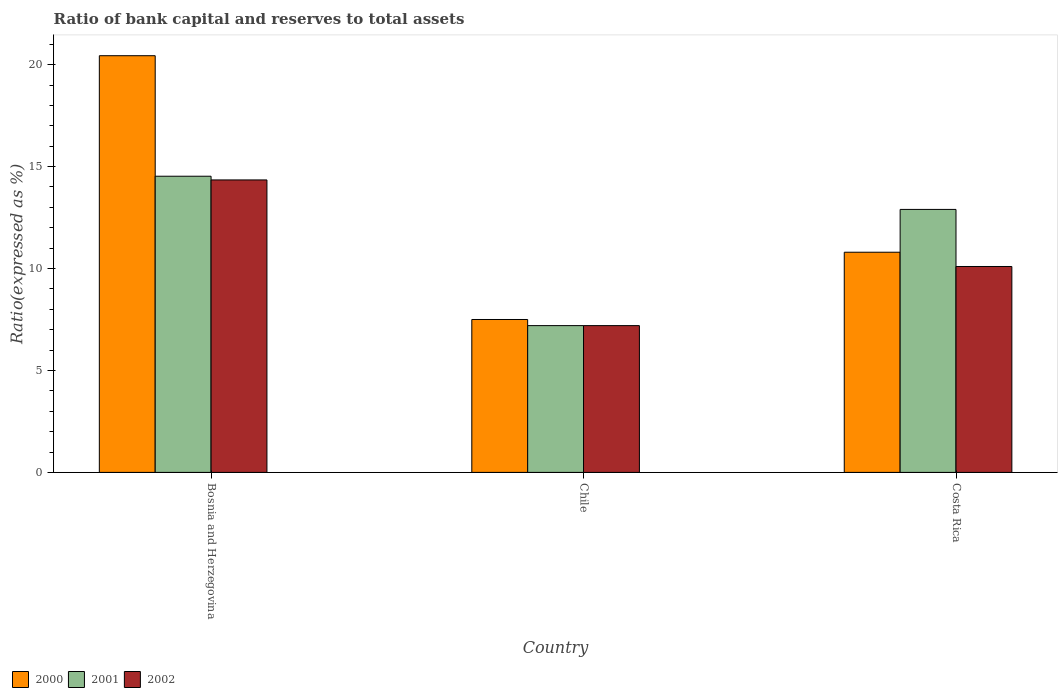How many different coloured bars are there?
Offer a terse response. 3. How many groups of bars are there?
Ensure brevity in your answer.  3. How many bars are there on the 3rd tick from the left?
Offer a very short reply. 3. What is the ratio of bank capital and reserves to total assets in 2001 in Costa Rica?
Keep it short and to the point. 12.9. Across all countries, what is the maximum ratio of bank capital and reserves to total assets in 2000?
Your response must be concise. 20.44. Across all countries, what is the minimum ratio of bank capital and reserves to total assets in 2000?
Provide a succinct answer. 7.5. In which country was the ratio of bank capital and reserves to total assets in 2001 maximum?
Provide a succinct answer. Bosnia and Herzegovina. In which country was the ratio of bank capital and reserves to total assets in 2002 minimum?
Provide a short and direct response. Chile. What is the total ratio of bank capital and reserves to total assets in 2001 in the graph?
Provide a short and direct response. 34.63. What is the difference between the ratio of bank capital and reserves to total assets in 2001 in Bosnia and Herzegovina and that in Costa Rica?
Your answer should be compact. 1.63. What is the difference between the ratio of bank capital and reserves to total assets in 2002 in Costa Rica and the ratio of bank capital and reserves to total assets in 2000 in Chile?
Offer a very short reply. 2.6. What is the average ratio of bank capital and reserves to total assets in 2001 per country?
Your answer should be compact. 11.54. What is the difference between the ratio of bank capital and reserves to total assets of/in 2002 and ratio of bank capital and reserves to total assets of/in 2000 in Bosnia and Herzegovina?
Make the answer very short. -6.09. In how many countries, is the ratio of bank capital and reserves to total assets in 2000 greater than 9 %?
Provide a succinct answer. 2. What is the ratio of the ratio of bank capital and reserves to total assets in 2001 in Bosnia and Herzegovina to that in Chile?
Offer a terse response. 2.02. Is the difference between the ratio of bank capital and reserves to total assets in 2002 in Bosnia and Herzegovina and Costa Rica greater than the difference between the ratio of bank capital and reserves to total assets in 2000 in Bosnia and Herzegovina and Costa Rica?
Give a very brief answer. No. What is the difference between the highest and the second highest ratio of bank capital and reserves to total assets in 2000?
Your response must be concise. -9.64. What is the difference between the highest and the lowest ratio of bank capital and reserves to total assets in 2000?
Offer a terse response. 12.94. In how many countries, is the ratio of bank capital and reserves to total assets in 2000 greater than the average ratio of bank capital and reserves to total assets in 2000 taken over all countries?
Your answer should be very brief. 1. Is the sum of the ratio of bank capital and reserves to total assets in 2002 in Chile and Costa Rica greater than the maximum ratio of bank capital and reserves to total assets in 2001 across all countries?
Ensure brevity in your answer.  Yes. What does the 2nd bar from the left in Chile represents?
Your answer should be very brief. 2001. What does the 3rd bar from the right in Costa Rica represents?
Your response must be concise. 2000. Is it the case that in every country, the sum of the ratio of bank capital and reserves to total assets in 2000 and ratio of bank capital and reserves to total assets in 2001 is greater than the ratio of bank capital and reserves to total assets in 2002?
Make the answer very short. Yes. Are all the bars in the graph horizontal?
Your response must be concise. No. Does the graph contain any zero values?
Ensure brevity in your answer.  No. What is the title of the graph?
Ensure brevity in your answer.  Ratio of bank capital and reserves to total assets. Does "1999" appear as one of the legend labels in the graph?
Offer a very short reply. No. What is the label or title of the X-axis?
Offer a very short reply. Country. What is the label or title of the Y-axis?
Ensure brevity in your answer.  Ratio(expressed as %). What is the Ratio(expressed as %) in 2000 in Bosnia and Herzegovina?
Give a very brief answer. 20.44. What is the Ratio(expressed as %) of 2001 in Bosnia and Herzegovina?
Provide a succinct answer. 14.53. What is the Ratio(expressed as %) of 2002 in Bosnia and Herzegovina?
Offer a very short reply. 14.35. What is the Ratio(expressed as %) of 2001 in Chile?
Make the answer very short. 7.2. What is the Ratio(expressed as %) in 2002 in Chile?
Offer a terse response. 7.2. What is the Ratio(expressed as %) of 2002 in Costa Rica?
Your answer should be very brief. 10.1. Across all countries, what is the maximum Ratio(expressed as %) in 2000?
Provide a succinct answer. 20.44. Across all countries, what is the maximum Ratio(expressed as %) of 2001?
Keep it short and to the point. 14.53. Across all countries, what is the maximum Ratio(expressed as %) of 2002?
Make the answer very short. 14.35. Across all countries, what is the minimum Ratio(expressed as %) in 2001?
Your answer should be compact. 7.2. What is the total Ratio(expressed as %) in 2000 in the graph?
Provide a short and direct response. 38.74. What is the total Ratio(expressed as %) in 2001 in the graph?
Your answer should be compact. 34.63. What is the total Ratio(expressed as %) of 2002 in the graph?
Your answer should be compact. 31.65. What is the difference between the Ratio(expressed as %) of 2000 in Bosnia and Herzegovina and that in Chile?
Ensure brevity in your answer.  12.94. What is the difference between the Ratio(expressed as %) in 2001 in Bosnia and Herzegovina and that in Chile?
Keep it short and to the point. 7.33. What is the difference between the Ratio(expressed as %) of 2002 in Bosnia and Herzegovina and that in Chile?
Offer a very short reply. 7.15. What is the difference between the Ratio(expressed as %) in 2000 in Bosnia and Herzegovina and that in Costa Rica?
Make the answer very short. 9.64. What is the difference between the Ratio(expressed as %) in 2001 in Bosnia and Herzegovina and that in Costa Rica?
Offer a very short reply. 1.63. What is the difference between the Ratio(expressed as %) in 2002 in Bosnia and Herzegovina and that in Costa Rica?
Provide a short and direct response. 4.25. What is the difference between the Ratio(expressed as %) of 2000 in Chile and that in Costa Rica?
Provide a short and direct response. -3.3. What is the difference between the Ratio(expressed as %) of 2002 in Chile and that in Costa Rica?
Offer a very short reply. -2.9. What is the difference between the Ratio(expressed as %) of 2000 in Bosnia and Herzegovina and the Ratio(expressed as %) of 2001 in Chile?
Keep it short and to the point. 13.24. What is the difference between the Ratio(expressed as %) of 2000 in Bosnia and Herzegovina and the Ratio(expressed as %) of 2002 in Chile?
Your answer should be very brief. 13.24. What is the difference between the Ratio(expressed as %) of 2001 in Bosnia and Herzegovina and the Ratio(expressed as %) of 2002 in Chile?
Your answer should be compact. 7.33. What is the difference between the Ratio(expressed as %) in 2000 in Bosnia and Herzegovina and the Ratio(expressed as %) in 2001 in Costa Rica?
Provide a succinct answer. 7.54. What is the difference between the Ratio(expressed as %) of 2000 in Bosnia and Herzegovina and the Ratio(expressed as %) of 2002 in Costa Rica?
Make the answer very short. 10.34. What is the difference between the Ratio(expressed as %) in 2001 in Bosnia and Herzegovina and the Ratio(expressed as %) in 2002 in Costa Rica?
Provide a succinct answer. 4.43. What is the difference between the Ratio(expressed as %) of 2000 in Chile and the Ratio(expressed as %) of 2001 in Costa Rica?
Ensure brevity in your answer.  -5.4. What is the difference between the Ratio(expressed as %) of 2000 in Chile and the Ratio(expressed as %) of 2002 in Costa Rica?
Offer a very short reply. -2.6. What is the difference between the Ratio(expressed as %) in 2001 in Chile and the Ratio(expressed as %) in 2002 in Costa Rica?
Make the answer very short. -2.9. What is the average Ratio(expressed as %) of 2000 per country?
Your answer should be very brief. 12.91. What is the average Ratio(expressed as %) in 2001 per country?
Make the answer very short. 11.54. What is the average Ratio(expressed as %) of 2002 per country?
Give a very brief answer. 10.55. What is the difference between the Ratio(expressed as %) of 2000 and Ratio(expressed as %) of 2001 in Bosnia and Herzegovina?
Provide a short and direct response. 5.91. What is the difference between the Ratio(expressed as %) of 2000 and Ratio(expressed as %) of 2002 in Bosnia and Herzegovina?
Give a very brief answer. 6.09. What is the difference between the Ratio(expressed as %) in 2001 and Ratio(expressed as %) in 2002 in Bosnia and Herzegovina?
Keep it short and to the point. 0.18. What is the difference between the Ratio(expressed as %) of 2000 and Ratio(expressed as %) of 2001 in Chile?
Give a very brief answer. 0.3. What is the difference between the Ratio(expressed as %) in 2000 and Ratio(expressed as %) in 2002 in Chile?
Make the answer very short. 0.3. What is the difference between the Ratio(expressed as %) of 2001 and Ratio(expressed as %) of 2002 in Costa Rica?
Offer a very short reply. 2.8. What is the ratio of the Ratio(expressed as %) in 2000 in Bosnia and Herzegovina to that in Chile?
Your answer should be very brief. 2.73. What is the ratio of the Ratio(expressed as %) in 2001 in Bosnia and Herzegovina to that in Chile?
Make the answer very short. 2.02. What is the ratio of the Ratio(expressed as %) of 2002 in Bosnia and Herzegovina to that in Chile?
Make the answer very short. 1.99. What is the ratio of the Ratio(expressed as %) of 2000 in Bosnia and Herzegovina to that in Costa Rica?
Your response must be concise. 1.89. What is the ratio of the Ratio(expressed as %) of 2001 in Bosnia and Herzegovina to that in Costa Rica?
Your response must be concise. 1.13. What is the ratio of the Ratio(expressed as %) of 2002 in Bosnia and Herzegovina to that in Costa Rica?
Your answer should be very brief. 1.42. What is the ratio of the Ratio(expressed as %) in 2000 in Chile to that in Costa Rica?
Give a very brief answer. 0.69. What is the ratio of the Ratio(expressed as %) in 2001 in Chile to that in Costa Rica?
Give a very brief answer. 0.56. What is the ratio of the Ratio(expressed as %) of 2002 in Chile to that in Costa Rica?
Your answer should be very brief. 0.71. What is the difference between the highest and the second highest Ratio(expressed as %) in 2000?
Offer a terse response. 9.64. What is the difference between the highest and the second highest Ratio(expressed as %) in 2001?
Your answer should be compact. 1.63. What is the difference between the highest and the second highest Ratio(expressed as %) in 2002?
Give a very brief answer. 4.25. What is the difference between the highest and the lowest Ratio(expressed as %) in 2000?
Keep it short and to the point. 12.94. What is the difference between the highest and the lowest Ratio(expressed as %) in 2001?
Ensure brevity in your answer.  7.33. What is the difference between the highest and the lowest Ratio(expressed as %) in 2002?
Your answer should be very brief. 7.15. 